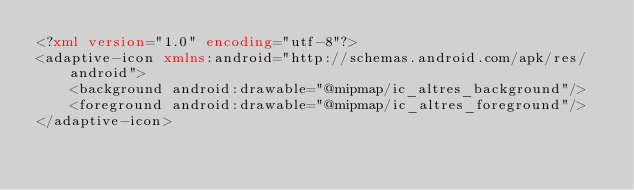Convert code to text. <code><loc_0><loc_0><loc_500><loc_500><_XML_><?xml version="1.0" encoding="utf-8"?>
<adaptive-icon xmlns:android="http://schemas.android.com/apk/res/android">
    <background android:drawable="@mipmap/ic_altres_background"/>
    <foreground android:drawable="@mipmap/ic_altres_foreground"/>
</adaptive-icon></code> 